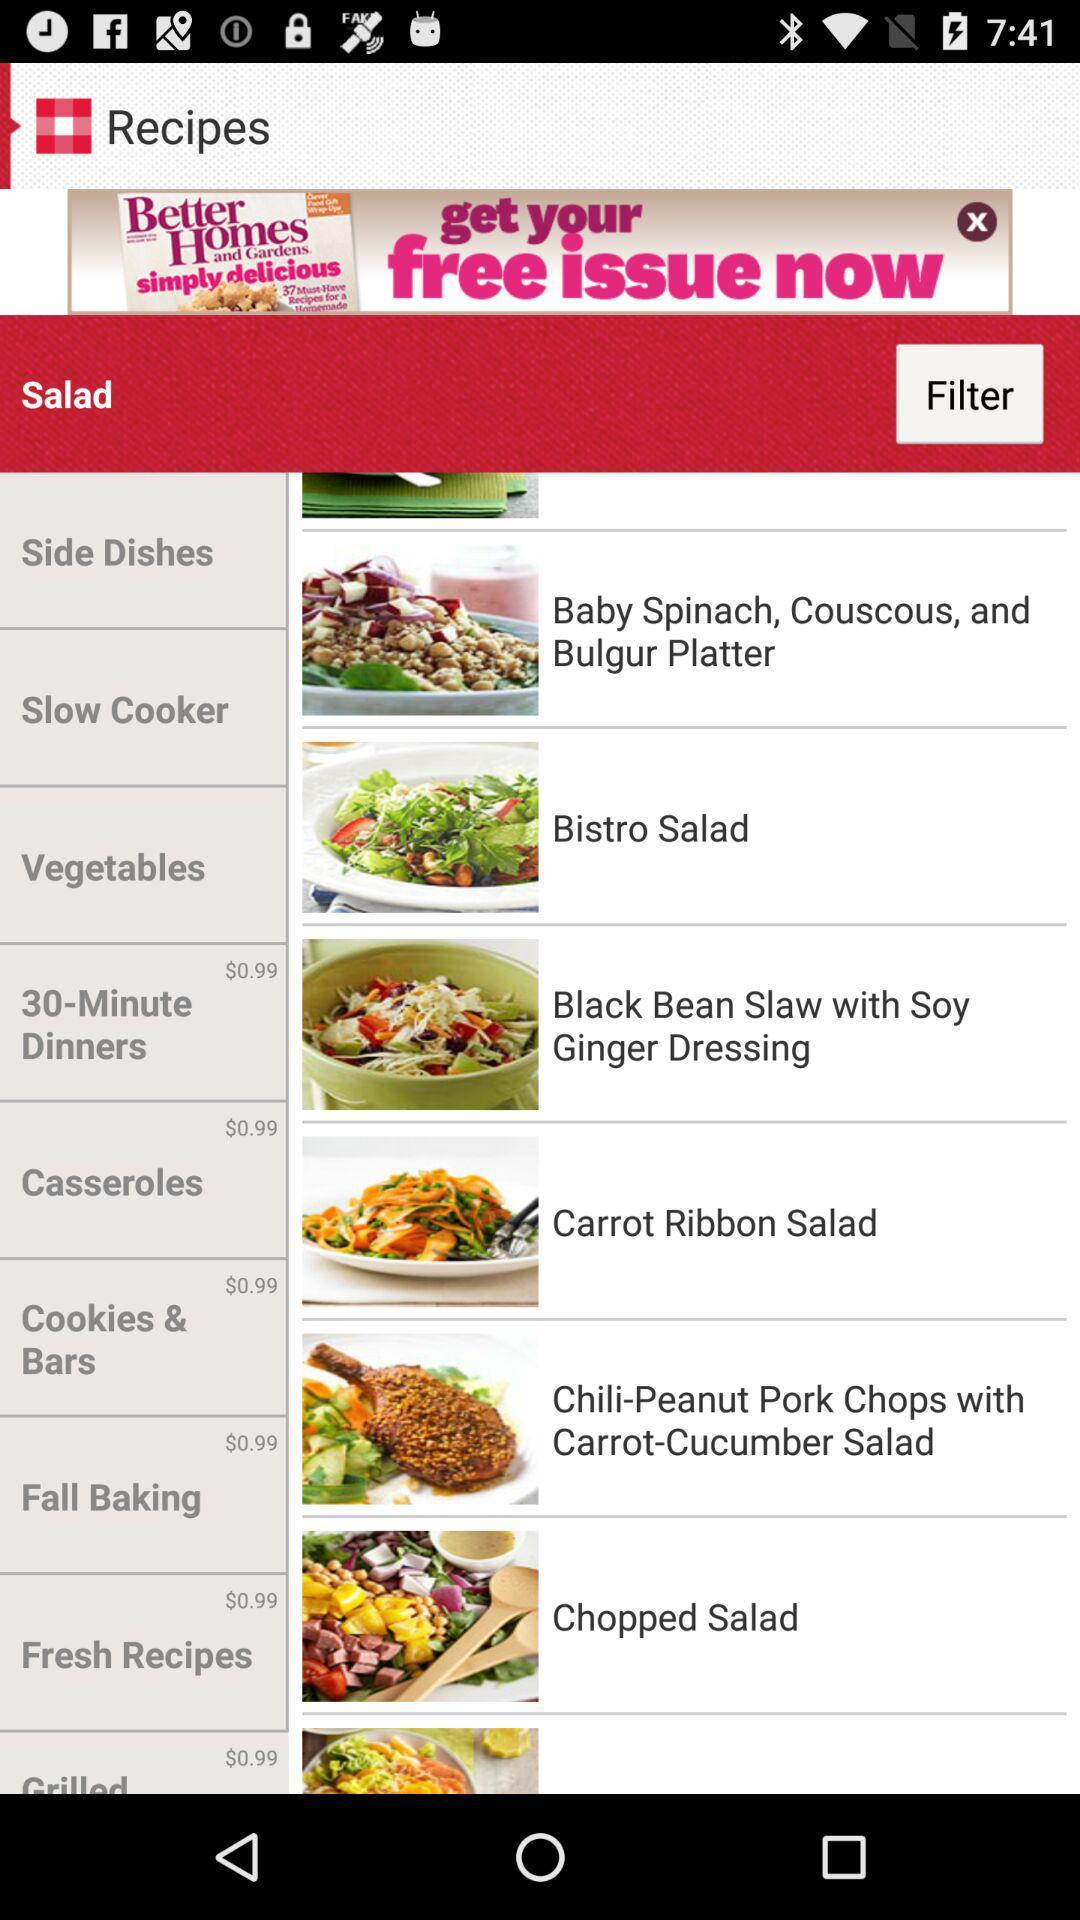What is the price of "Cookies & Bars"? The price is $0.99. 